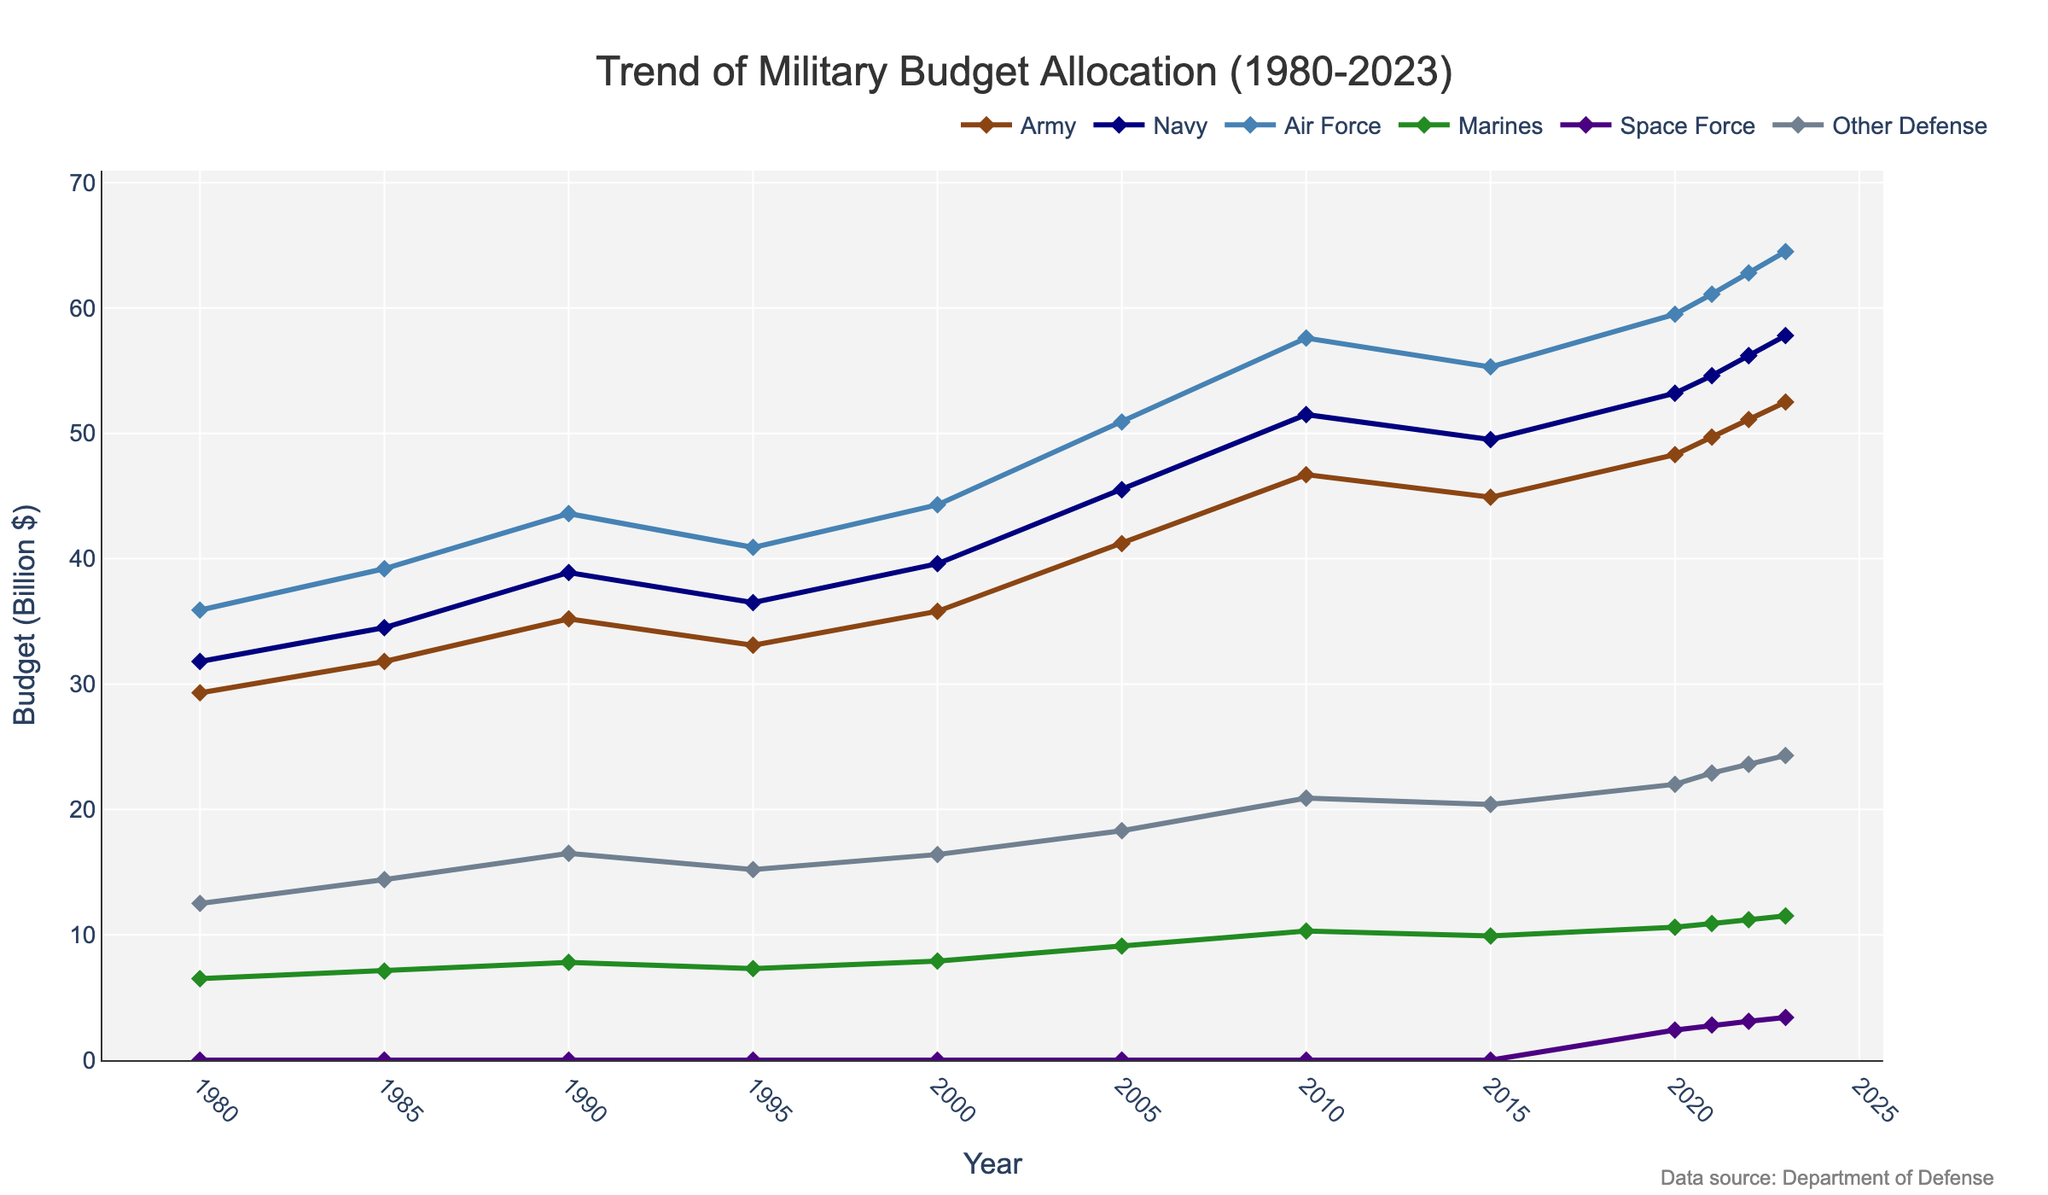Which department saw the highest budget increase from 1980 to 2023? To find the department with the highest budget increase, calculate the difference between the 2023 and 1980 budgets for each department. The Air Force increased from 35.9 in 1980 to 64.5 in 2023, giving a difference of 28.6 billion dollars, which is the highest among all departments.
Answer: Air Force What was the total defense budget allocation in 2023? Sum the budgets of all departments for 2023. This is 52.5 (Army) + 57.8 (Navy) + 64.5 (Air Force) + 11.5 (Marines) + 3.4 (Space Force) + 24.3 (Other Defense) = 213.0 billion dollars.
Answer: 213.0 How did the budget for the Marine Corps change from 1980 to 2023? Subtract the 1980 Marine Corps budget from the 2023 Marine Corps budget. The Marine Corps budget increased from 6.5 billion in 1980 to 11.5 billion in 2023. Therefore, the change is 11.5 - 6.5 = 5 billion dollars.
Answer: 5 billion dollars Which department had the smallest budget in 2020 and what was it? Look at the budget values for 2020 and identify the smallest one. The Space Force had the smallest budget in 2020 amounting to 2.4 billion dollars.
Answer: Space Force, 2.4 billion dollars Between 2019 and 2021, which department had the largest budget growth? The budget growth can be found by subtracting the 2019 value from the 2021 budget value for each department. The Air Force budget grew from 55.3 (2019) to 61.1 (2021), making a difference of 61.1 - 55.3 = 5.8 billion dollars, the highest growth within this period.
Answer: Air Force, 5.8 billion dollars Which department shows a continuous budget increase from 1980 to 2023? To determine this, check if any department’s budget never decreased in any year within the given period. The Navy's budget consistently increased from 1980 to 2023.
Answer: Navy What was the average annual budget allocation for the Army between 1980 and 2023? Sum the Army budgets across all years and divide by the number of years. The total sum is 529.6 billion (sum of all years from 1980 to 2023). There are 12 data points (years), so the average is 529.6 / 12 = 44.13 billion dollars.
Answer: 44.13 billion dollars Which year saw the biggest increase in budget for the Space Force compared to the previous year? Compare the Space Force budgets year over year from 2020 onward and identify the year with the largest increase. The largest increase occurred from 2020 (2.4) to 2021 (2.8), with an increment of 0.4 billion dollars.
Answer: 2021 How did the total budget 'Other Defense' change from 2005 to 2023? Subtract the 2005 'Other Defense' budget from the 2023 'Other Defense' budget. The change is 24.3 (2023) - 18.3 (2005) = 6 billion dollars increase.
Answer: 6 billion dollars 